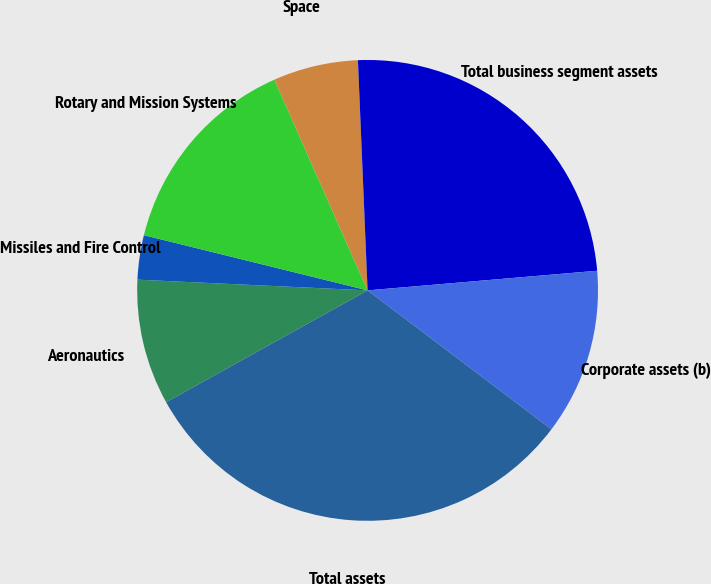Convert chart to OTSL. <chart><loc_0><loc_0><loc_500><loc_500><pie_chart><fcel>Aeronautics<fcel>Missiles and Fire Control<fcel>Rotary and Mission Systems<fcel>Space<fcel>Total business segment assets<fcel>Corporate assets (b)<fcel>Total assets<nl><fcel>8.81%<fcel>3.11%<fcel>14.52%<fcel>5.96%<fcel>24.31%<fcel>11.66%<fcel>31.63%<nl></chart> 